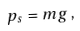Convert formula to latex. <formula><loc_0><loc_0><loc_500><loc_500>p _ { s } = m g \, ,</formula> 